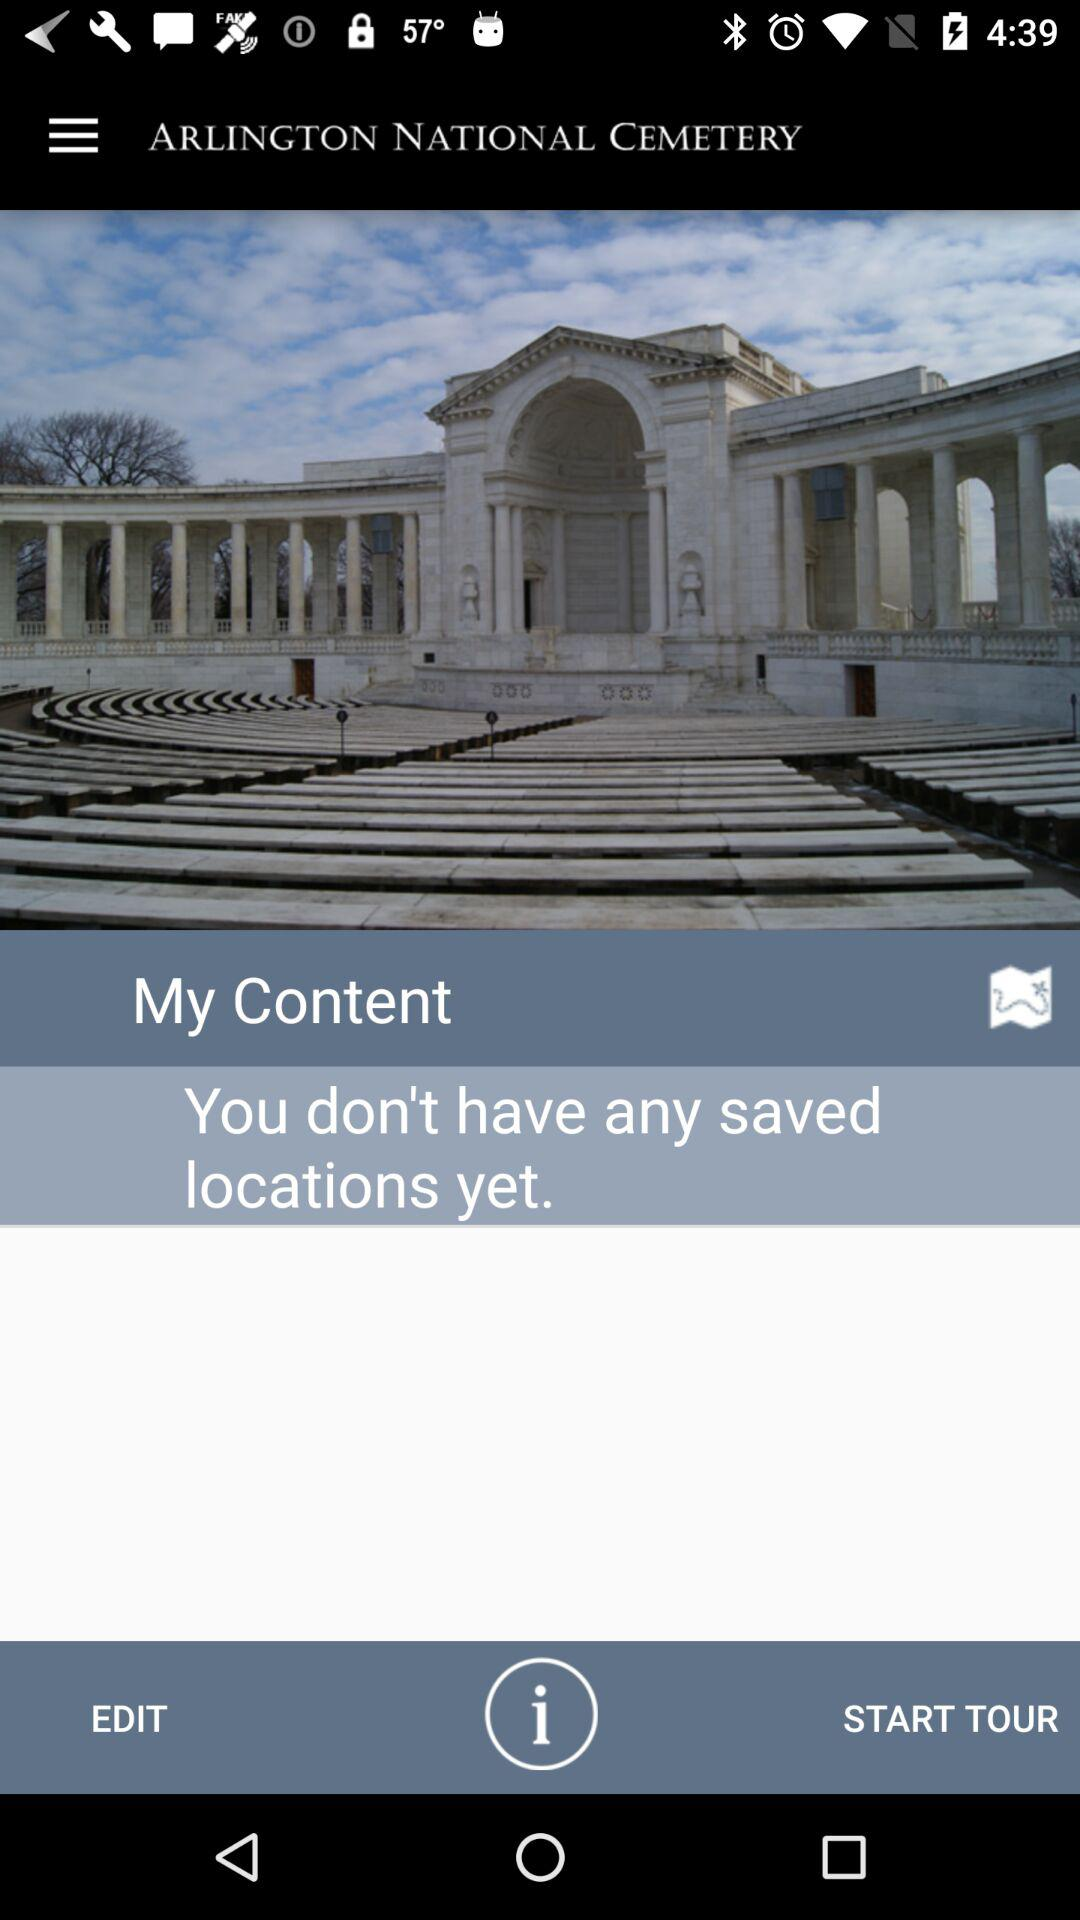How many locations do I have saved?
Answer the question using a single word or phrase. 0 